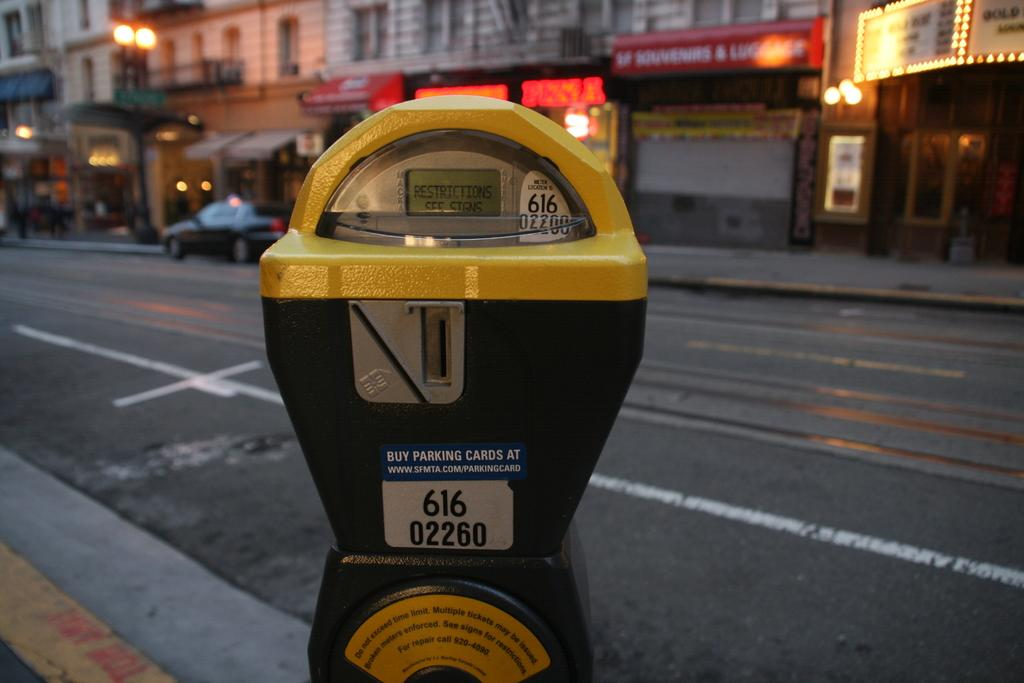<image>
Present a compact description of the photo's key features. A yellow parking meter with the location id. 616 02260 